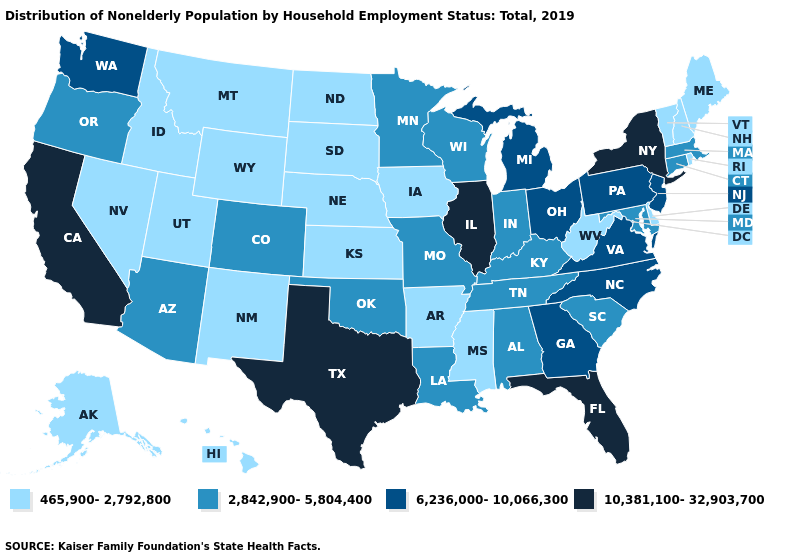Among the states that border Michigan , does Ohio have the lowest value?
Be succinct. No. Does Delaware have a higher value than Nevada?
Be succinct. No. Which states hav the highest value in the Northeast?
Be succinct. New York. What is the highest value in the Northeast ?
Quick response, please. 10,381,100-32,903,700. Which states hav the highest value in the South?
Be succinct. Florida, Texas. What is the highest value in the West ?
Quick response, please. 10,381,100-32,903,700. What is the lowest value in states that border New Mexico?
Keep it brief. 465,900-2,792,800. What is the value of Nebraska?
Answer briefly. 465,900-2,792,800. What is the lowest value in the MidWest?
Answer briefly. 465,900-2,792,800. What is the value of Hawaii?
Be succinct. 465,900-2,792,800. Does Delaware have a lower value than Virginia?
Be succinct. Yes. Among the states that border Iowa , which have the lowest value?
Keep it brief. Nebraska, South Dakota. What is the value of Maine?
Answer briefly. 465,900-2,792,800. What is the lowest value in the USA?
Answer briefly. 465,900-2,792,800. Name the states that have a value in the range 2,842,900-5,804,400?
Concise answer only. Alabama, Arizona, Colorado, Connecticut, Indiana, Kentucky, Louisiana, Maryland, Massachusetts, Minnesota, Missouri, Oklahoma, Oregon, South Carolina, Tennessee, Wisconsin. 